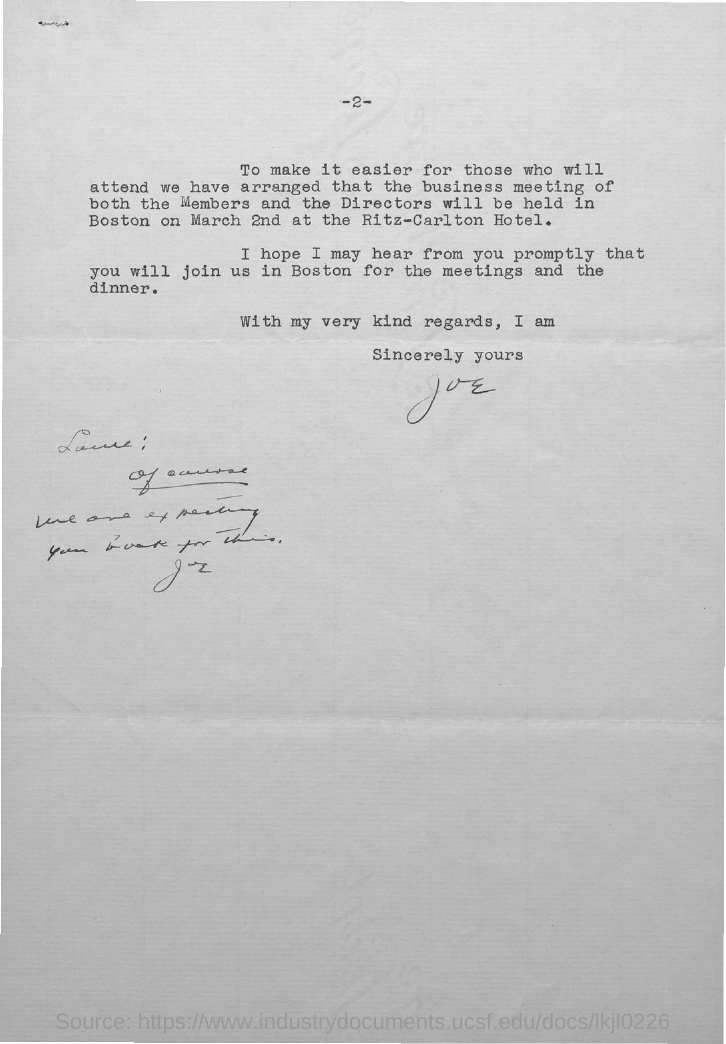What is the page no mentioned in this document?
Ensure brevity in your answer.  2. Who is the sender of this letter?
Offer a terse response. Joe. 